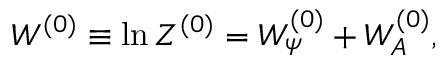<formula> <loc_0><loc_0><loc_500><loc_500>W ^ { ( 0 ) } \equiv \ln \, Z ^ { ( 0 ) } = W _ { \psi } ^ { ( 0 ) } + W _ { A } ^ { ( 0 ) } ,</formula> 